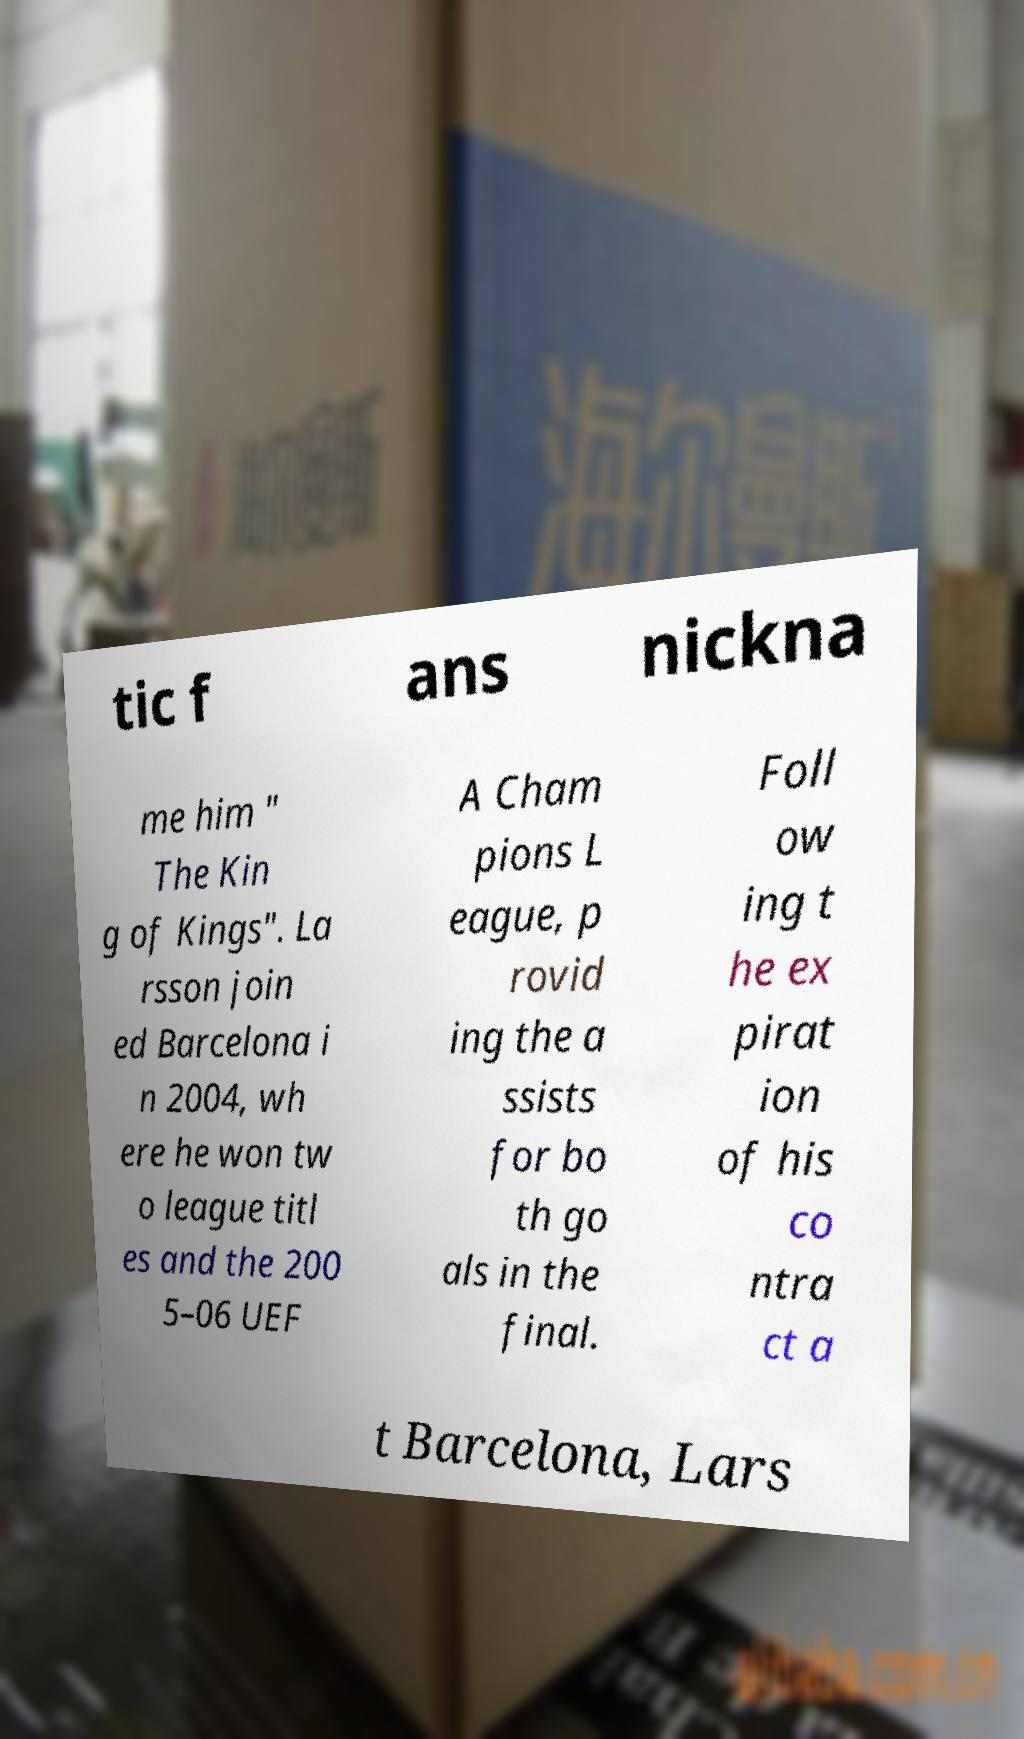What messages or text are displayed in this image? I need them in a readable, typed format. tic f ans nickna me him " The Kin g of Kings". La rsson join ed Barcelona i n 2004, wh ere he won tw o league titl es and the 200 5–06 UEF A Cham pions L eague, p rovid ing the a ssists for bo th go als in the final. Foll ow ing t he ex pirat ion of his co ntra ct a t Barcelona, Lars 